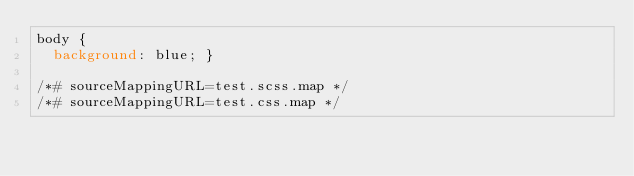Convert code to text. <code><loc_0><loc_0><loc_500><loc_500><_CSS_>body {
  background: blue; }

/*# sourceMappingURL=test.scss.map */
/*# sourceMappingURL=test.css.map */</code> 